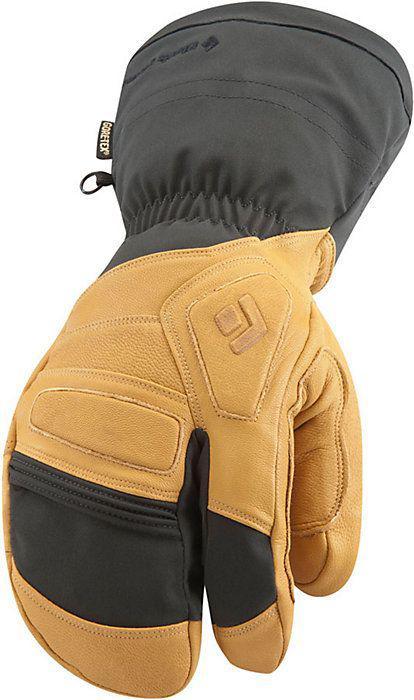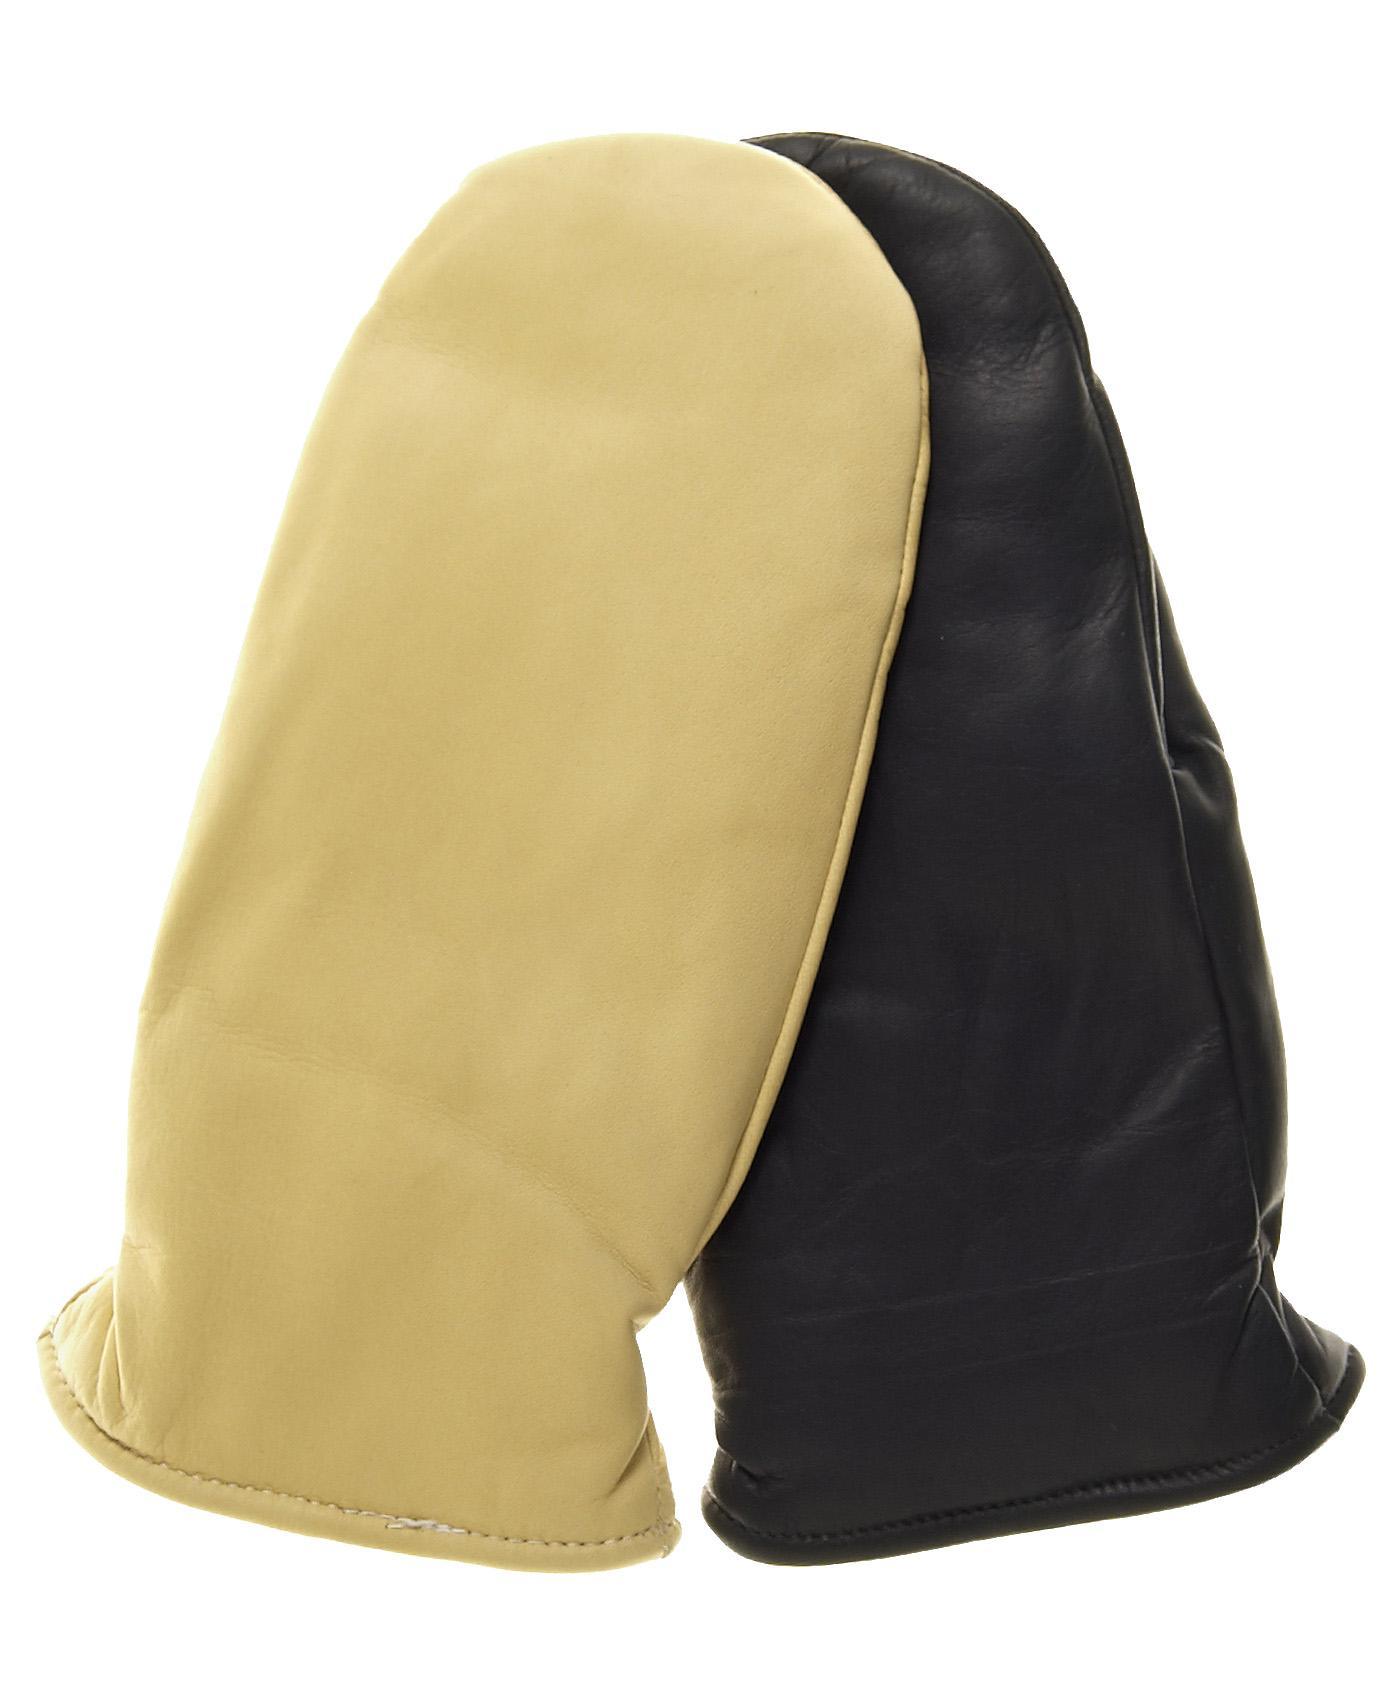The first image is the image on the left, the second image is the image on the right. Evaluate the accuracy of this statement regarding the images: "One image shows exactly one buff beige mitten overlapping one black mitten.". Is it true? Answer yes or no. Yes. The first image is the image on the left, the second image is the image on the right. Considering the images on both sides, is "There are three mittens in the image on the left and a single pair in the image on the right." valid? Answer yes or no. No. 